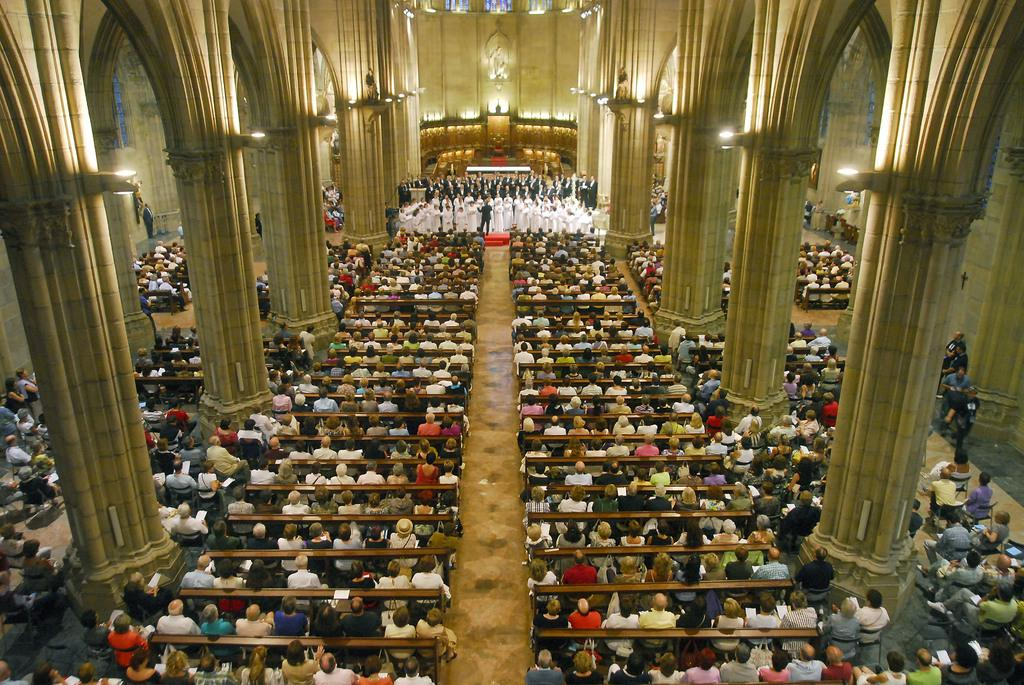What are the people in the image doing? There are persons sitting and standing in the image. What architectural features can be seen in the image? There are pillars in the image. What can be used for illumination in the image? There are lights in the image. What type of discussion is taking place in the image? There is no discussion taking place in the image; it only shows people sitting and standing, as well as pillars and lights. 